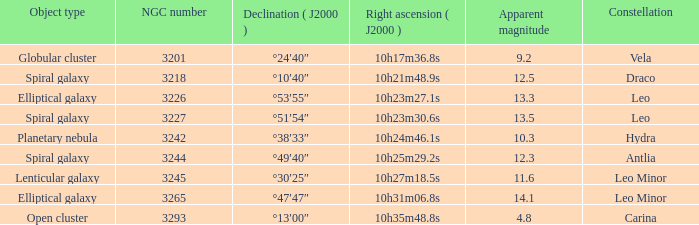What is the Apparent magnitude of a globular cluster? 9.2. 